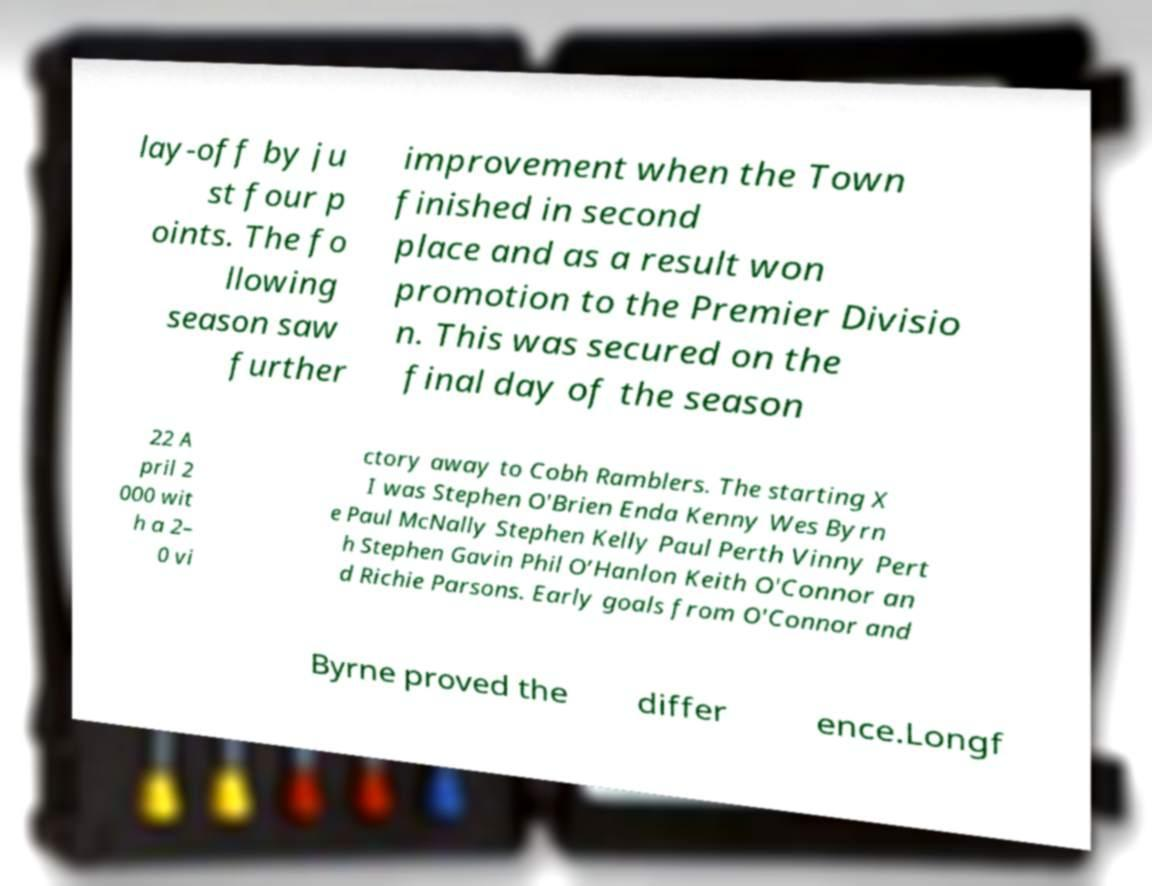What messages or text are displayed in this image? I need them in a readable, typed format. lay-off by ju st four p oints. The fo llowing season saw further improvement when the Town finished in second place and as a result won promotion to the Premier Divisio n. This was secured on the final day of the season 22 A pril 2 000 wit h a 2– 0 vi ctory away to Cobh Ramblers. The starting X I was Stephen O'Brien Enda Kenny Wes Byrn e Paul McNally Stephen Kelly Paul Perth Vinny Pert h Stephen Gavin Phil O’Hanlon Keith O'Connor an d Richie Parsons. Early goals from O'Connor and Byrne proved the differ ence.Longf 